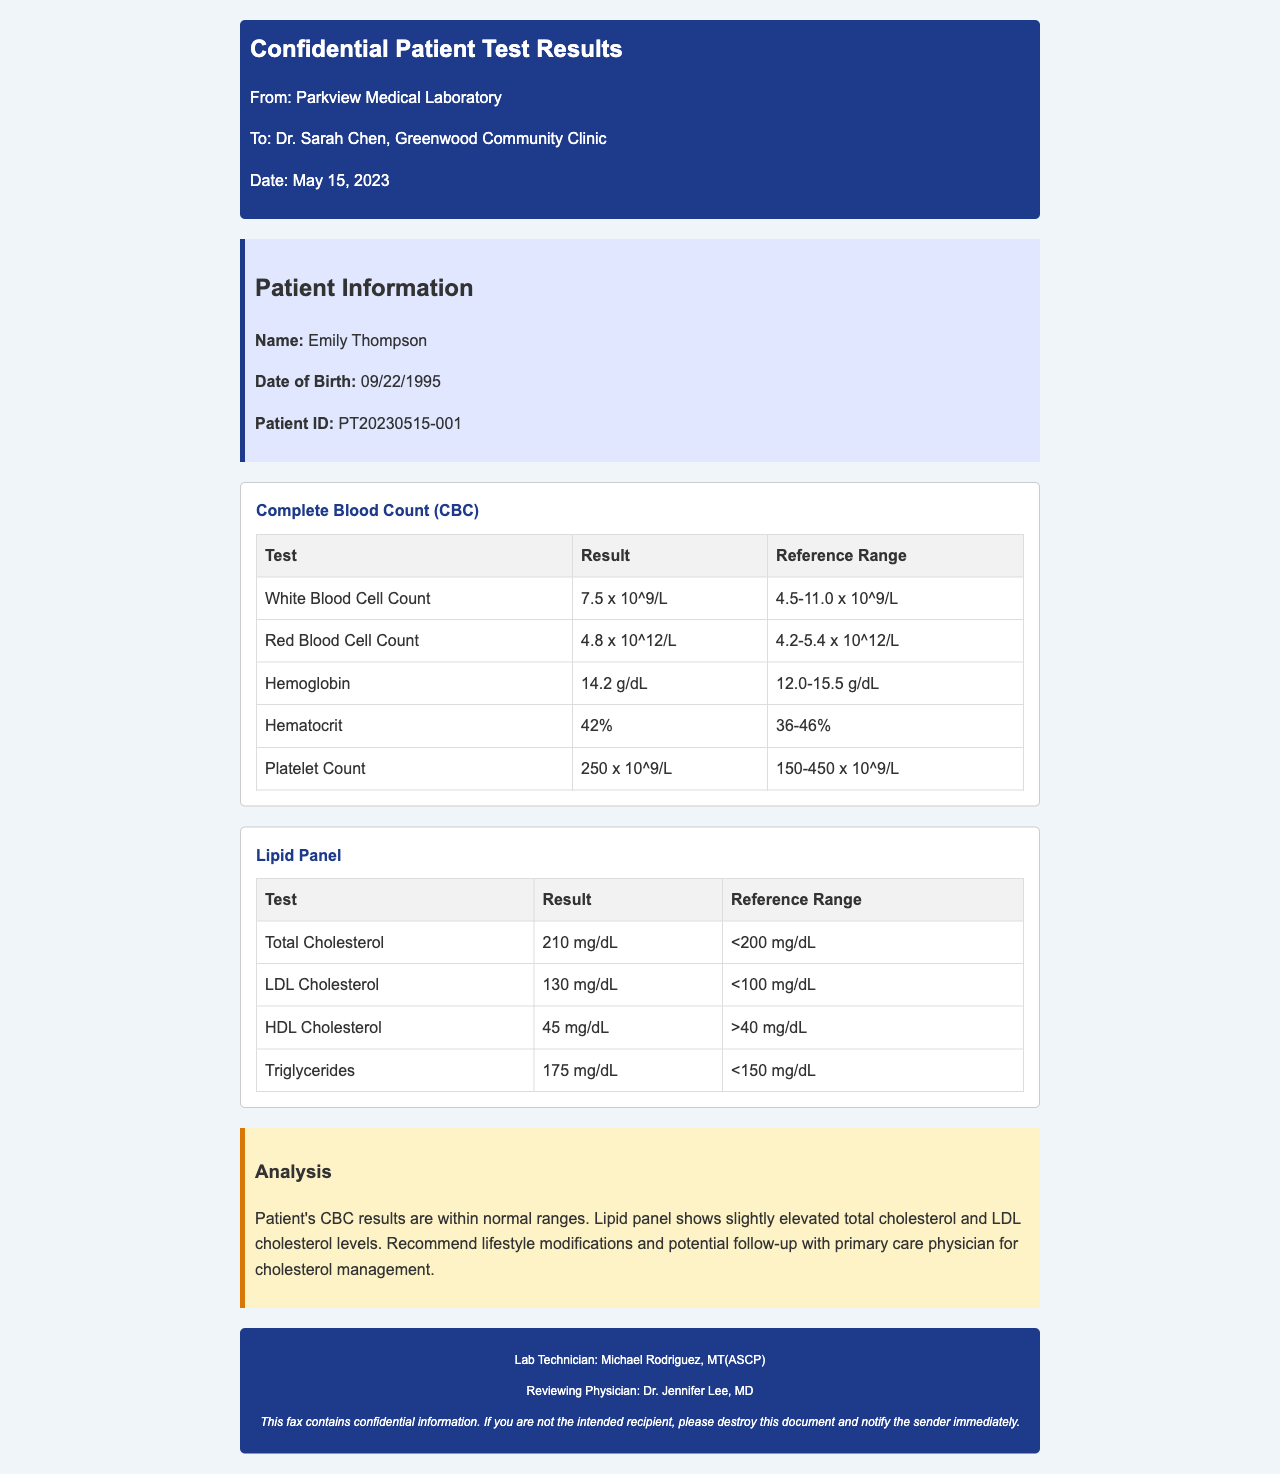What is the patient's name? The patient's name is provided in the patient information section of the document.
Answer: Emily Thompson What is the date of birth? The date of birth is specified in the patient information section.
Answer: 09/22/1995 What is the patient's ID? The patient ID is mentioned in the patient information, which uniquely identifies the patient.
Answer: PT20230515-001 What is the result of the White Blood Cell Count? The result is listed in the Complete Blood Count (CBC) test results.
Answer: 7.5 x 10^9/L What is the reference range for Total Cholesterol? The reference range indicates the normal levels for the Total Cholesterol test.
Answer: <200 mg/dL What recommendation is made for the patient's cholesterol management? The analysis section provides an interpretation of the lipid panel results and the recommendations.
Answer: Lifestyle modifications How many tests are in the Complete Blood Count? The number of tests can be counted from the table in the test results section for the CBC.
Answer: 5 What is the date of the document? The date is referenced in the header of the fax.
Answer: May 15, 2023 Who reviewed the document? The reviewing physician is listed in the footer of the fax.
Answer: Dr. Jennifer Lee, MD 